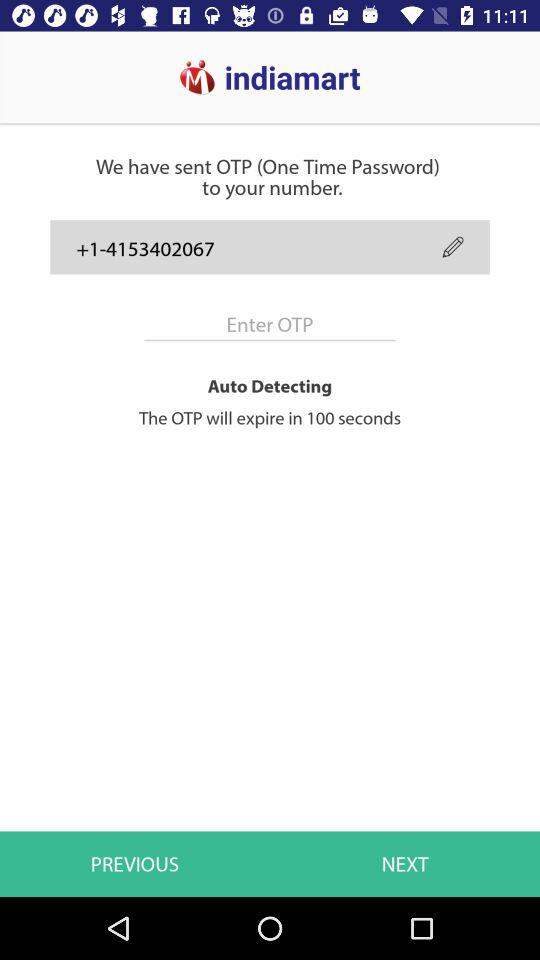How many seconds are left before the OTP expires?
Answer the question using a single word or phrase. 100 